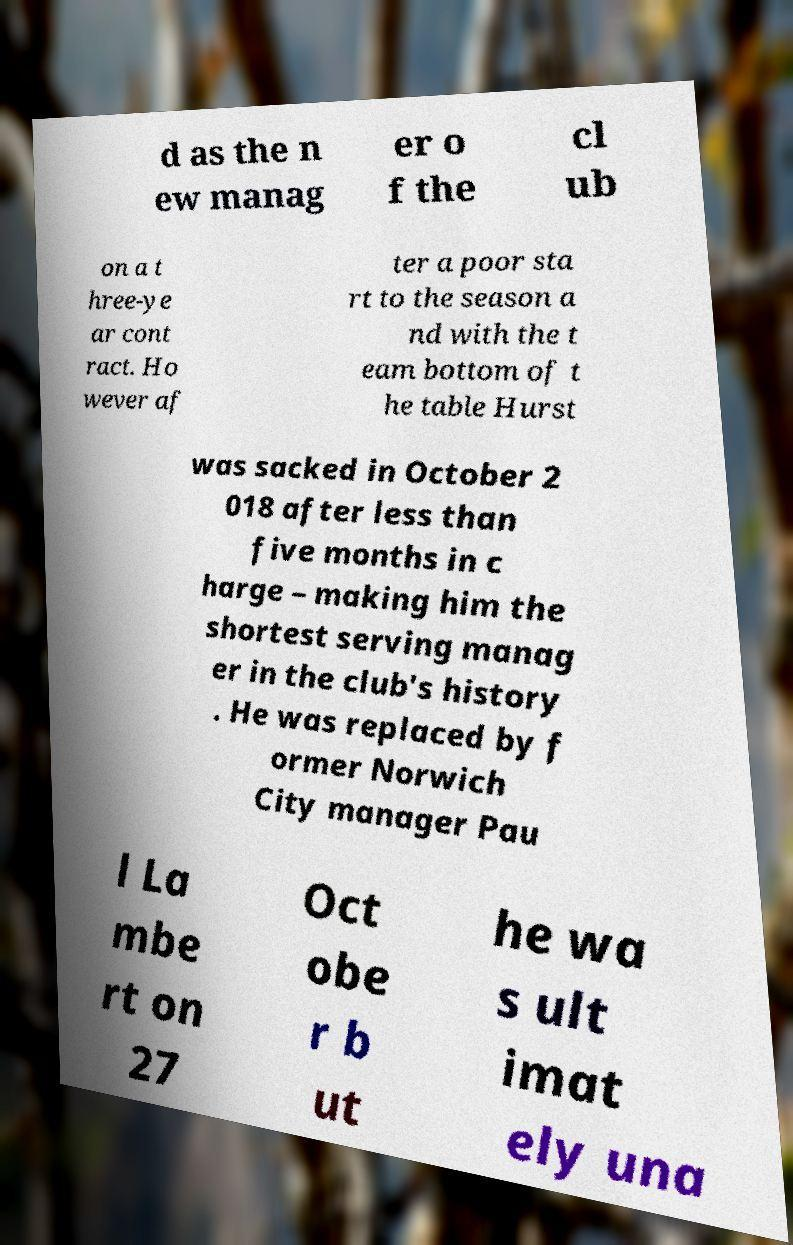What messages or text are displayed in this image? I need them in a readable, typed format. d as the n ew manag er o f the cl ub on a t hree-ye ar cont ract. Ho wever af ter a poor sta rt to the season a nd with the t eam bottom of t he table Hurst was sacked in October 2 018 after less than five months in c harge – making him the shortest serving manag er in the club's history . He was replaced by f ormer Norwich City manager Pau l La mbe rt on 27 Oct obe r b ut he wa s ult imat ely una 